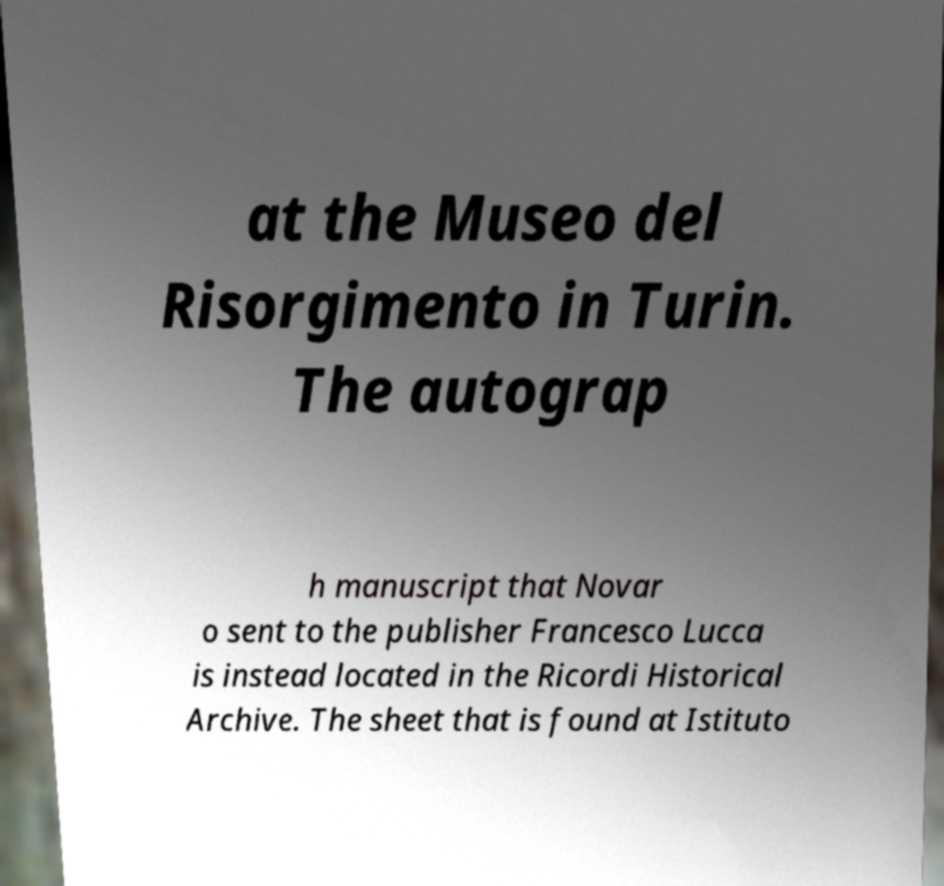Please identify and transcribe the text found in this image. at the Museo del Risorgimento in Turin. The autograp h manuscript that Novar o sent to the publisher Francesco Lucca is instead located in the Ricordi Historical Archive. The sheet that is found at Istituto 